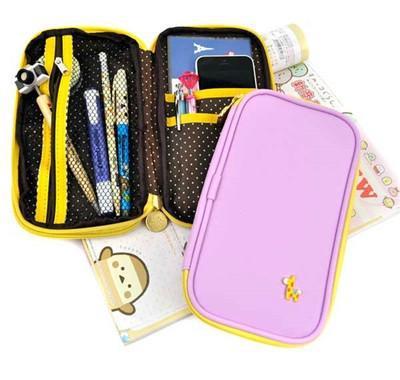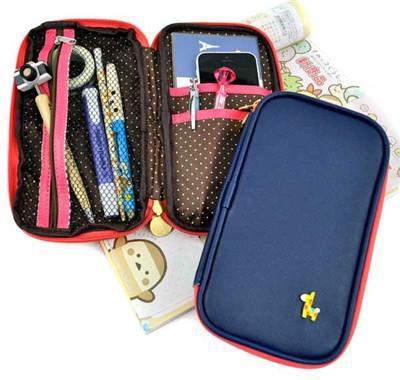The first image is the image on the left, the second image is the image on the right. Analyze the images presented: Is the assertion "There are no more than two camera pencil toppers in both sets of images." valid? Answer yes or no. Yes. The first image is the image on the left, the second image is the image on the right. Assess this claim about the two images: "Each image includes a closed zipper case to the right of an open, filled pencil case.". Correct or not? Answer yes or no. Yes. 